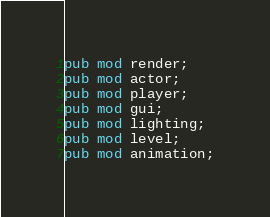Convert code to text. <code><loc_0><loc_0><loc_500><loc_500><_Rust_>pub mod render;
pub mod actor;
pub mod player;
pub mod gui;
pub mod lighting;
pub mod level;
pub mod animation;</code> 